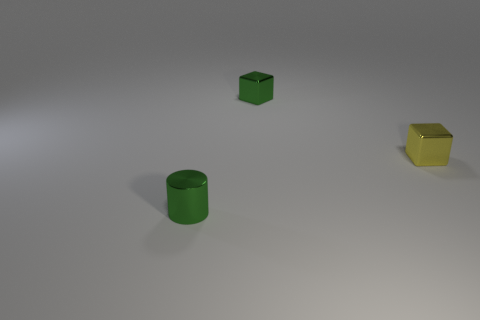How many other objects are there of the same color as the small metallic cylinder?
Provide a succinct answer. 1. How many objects are gray metallic cubes or yellow objects?
Provide a short and direct response. 1. What number of objects are green shiny cubes or small metal objects that are behind the shiny cylinder?
Offer a terse response. 2. Is the yellow object made of the same material as the cylinder?
Make the answer very short. Yes. Is the number of yellow blocks greater than the number of large yellow metallic blocks?
Your answer should be compact. Yes. Does the small green shiny object that is right of the cylinder have the same shape as the tiny yellow metal thing?
Provide a succinct answer. Yes. Are there fewer tiny yellow cubes than large brown balls?
Make the answer very short. No. Is the color of the metal cylinder the same as the metallic cube in front of the small green cube?
Make the answer very short. No. Is the number of small metal cubes on the right side of the small yellow cube less than the number of small green objects?
Give a very brief answer. Yes. How many small yellow objects are there?
Provide a succinct answer. 1. 